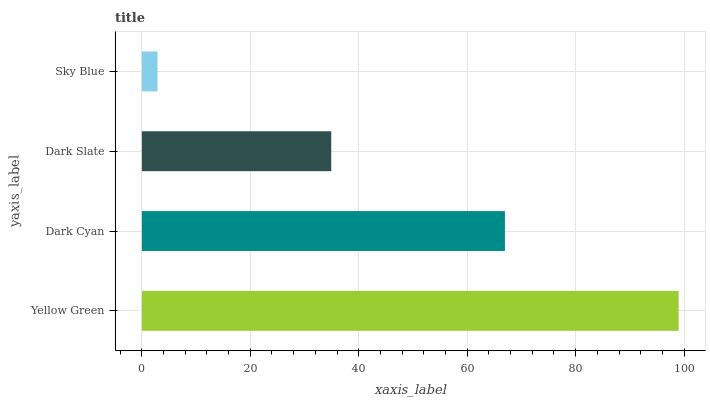Is Sky Blue the minimum?
Answer yes or no. Yes. Is Yellow Green the maximum?
Answer yes or no. Yes. Is Dark Cyan the minimum?
Answer yes or no. No. Is Dark Cyan the maximum?
Answer yes or no. No. Is Yellow Green greater than Dark Cyan?
Answer yes or no. Yes. Is Dark Cyan less than Yellow Green?
Answer yes or no. Yes. Is Dark Cyan greater than Yellow Green?
Answer yes or no. No. Is Yellow Green less than Dark Cyan?
Answer yes or no. No. Is Dark Cyan the high median?
Answer yes or no. Yes. Is Dark Slate the low median?
Answer yes or no. Yes. Is Dark Slate the high median?
Answer yes or no. No. Is Dark Cyan the low median?
Answer yes or no. No. 